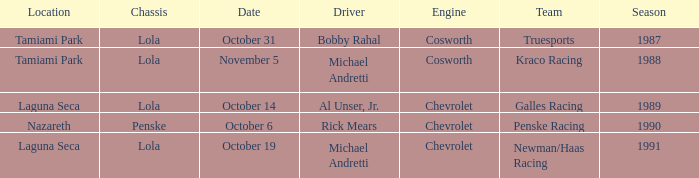What engine does Galles Racing use? Chevrolet. 